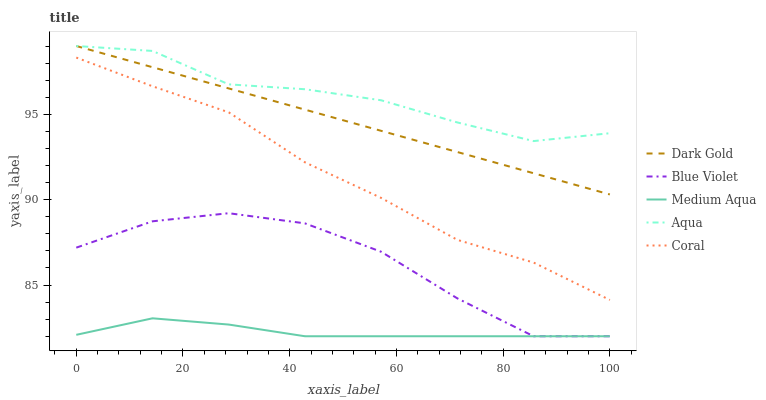Does Medium Aqua have the minimum area under the curve?
Answer yes or no. Yes. Does Aqua have the maximum area under the curve?
Answer yes or no. Yes. Does Coral have the minimum area under the curve?
Answer yes or no. No. Does Coral have the maximum area under the curve?
Answer yes or no. No. Is Dark Gold the smoothest?
Answer yes or no. Yes. Is Blue Violet the roughest?
Answer yes or no. Yes. Is Coral the smoothest?
Answer yes or no. No. Is Coral the roughest?
Answer yes or no. No. Does Medium Aqua have the lowest value?
Answer yes or no. Yes. Does Coral have the lowest value?
Answer yes or no. No. Does Dark Gold have the highest value?
Answer yes or no. Yes. Does Coral have the highest value?
Answer yes or no. No. Is Blue Violet less than Aqua?
Answer yes or no. Yes. Is Dark Gold greater than Coral?
Answer yes or no. Yes. Does Medium Aqua intersect Blue Violet?
Answer yes or no. Yes. Is Medium Aqua less than Blue Violet?
Answer yes or no. No. Is Medium Aqua greater than Blue Violet?
Answer yes or no. No. Does Blue Violet intersect Aqua?
Answer yes or no. No. 